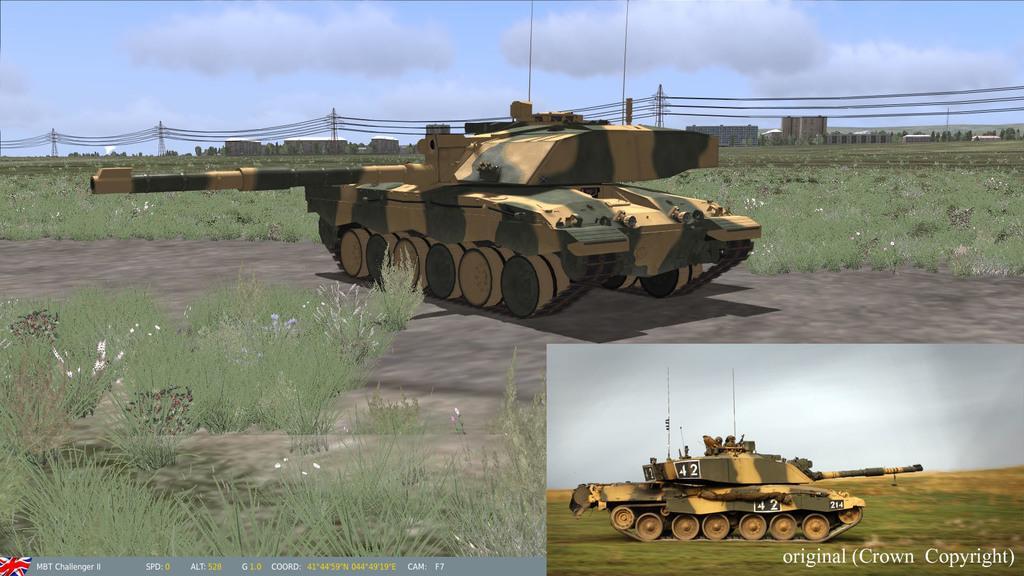Describe this image in one or two sentences. In the image we can see there is a collage of pictures in which there is a war tank and there are plants on the ground. Behind there are buildings and there is a electrical light poles and wires. There is a cloudy sky. 